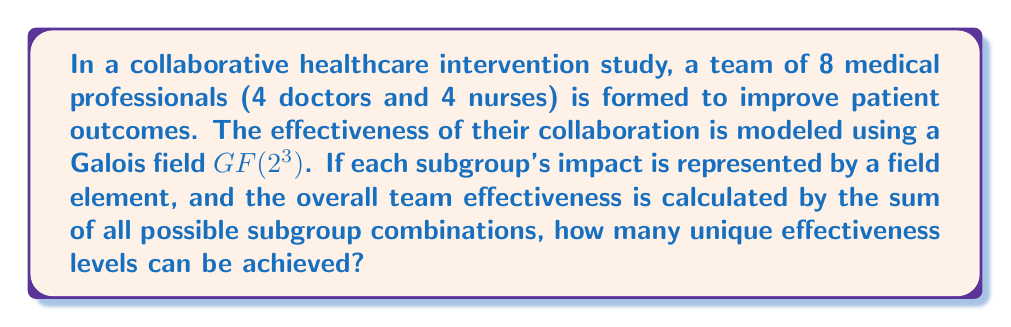Give your solution to this math problem. To solve this problem, we'll use concepts from Galois theory and combinatorics:

1) First, we need to understand the Galois field $GF(2^3)$:
   - This field has $2^3 = 8$ elements
   - The elements are typically represented as {0, 1, α, α^2, α^3, α^4, α^5, α^6}, where α is a primitive element

2) Now, let's consider the subgroups:
   - Total number of subgroups = $2^8 - 1 = 255$ (excluding the empty set)

3) Each subgroup's impact is represented by a field element, so there are 8 possible impact levels for each subgroup.

4) The overall team effectiveness is the sum of all subgroup combinations. In $GF(2^3)$, addition is performed modulo 2 for each power of α.

5) To find the number of unique effectiveness levels, we need to consider all possible sums of the field elements:
   - The sum of any combination of field elements will always result in another field element
   - Therefore, the maximum number of unique effectiveness levels is limited by the number of elements in $GF(2^3)$, which is 8

6) However, we need to consider that the sum could also be zero, which represents no overall effect.

Thus, the number of unique effectiveness levels that can be achieved is equal to the number of elements in $GF(2^3)$, which is 8.
Answer: 8 